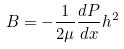<formula> <loc_0><loc_0><loc_500><loc_500>B = - \frac { 1 } { 2 \mu } \frac { d P } { d x } h ^ { 2 }</formula> 